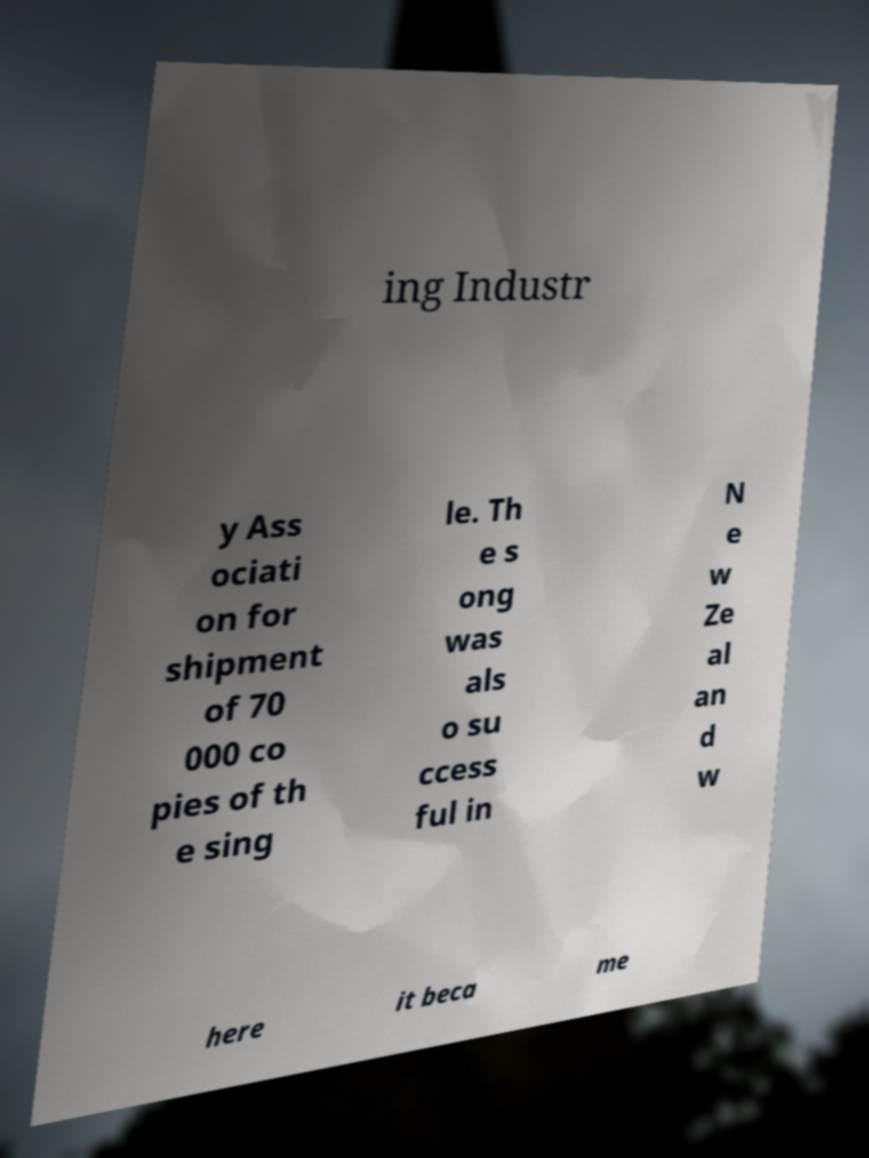Could you assist in decoding the text presented in this image and type it out clearly? ing Industr y Ass ociati on for shipment of 70 000 co pies of th e sing le. Th e s ong was als o su ccess ful in N e w Ze al an d w here it beca me 